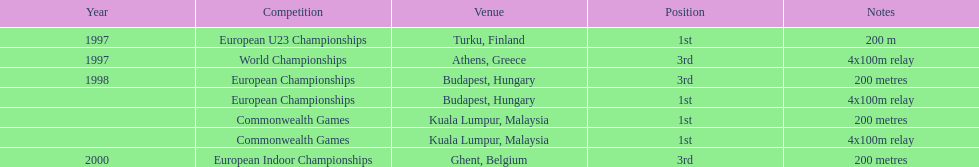How many events in budapest, hungary had participants achieving the 1st position? 1. 